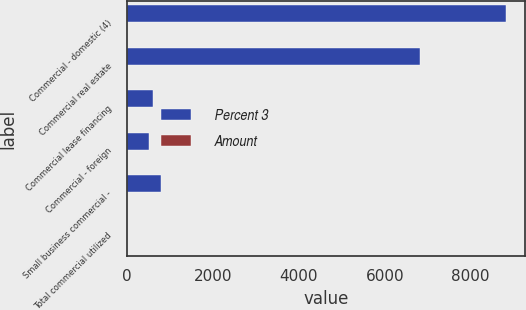<chart> <loc_0><loc_0><loc_500><loc_500><stacked_bar_chart><ecel><fcel>Commercial - domestic (4)<fcel>Commercial real estate<fcel>Commercial lease financing<fcel>Commercial - foreign<fcel>Small business commercial -<fcel>Total commercial utilized<nl><fcel>Percent 3<fcel>8829<fcel>6825<fcel>594<fcel>509<fcel>796<fcel>10.35<nl><fcel>Amount<fcel>3.37<fcel>10.35<fcel>2.63<fcel>0.98<fcel>4.46<fcel>4.17<nl></chart> 